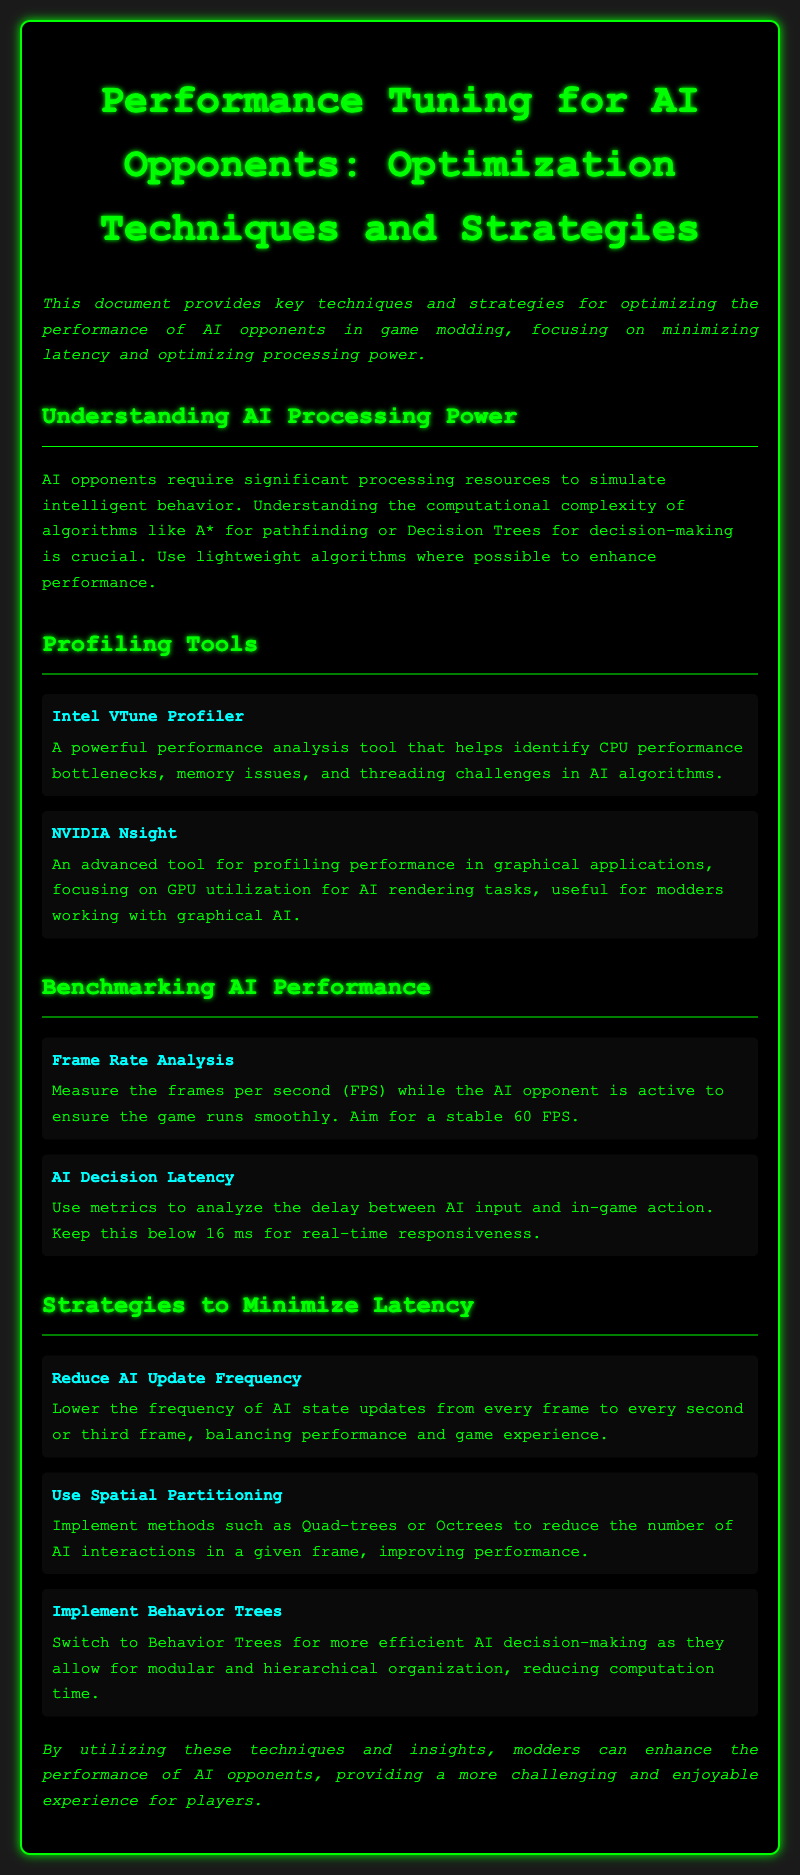What is the title of the document? The title of the document is provided at the top of the content, indicating the main subject covered.
Answer: Performance Tuning for AI Opponents: Optimization Techniques and Strategies What are the two profiling tools mentioned in the document? The document lists specific tools used for performance analysis which are detailed in the profiling tools section.
Answer: Intel VTune Profiler, NVIDIA Nsight What is the stable frame rate to aim for according to the benchmarks? The document specifies a target frame rate to ensure smooth gameplay as mentioned in the benchmarking section.
Answer: 60 FPS What is the maximum AI decision latency recommended for real-time responsiveness? The document outlines a threshold for AI decision latency to achieve a responsive gaming experience.
Answer: 16 ms Which strategy involves reducing AI state updates? This strategy is detailed in the strategies section where various methods to improve performance are discussed.
Answer: Reduce AI Update Frequency What organization method is suggested for efficient AI decision-making? The document provides specific methods for improving decision-making efficiency among AI opponents.
Answer: Behavior Trees What is one method mentioned for spatial partitioning? The document suggests techniques used to organize space and improve AI performance, specifying at least one method.
Answer: Quad-trees What is the primary focus of the introduction? The introduction outlines the objectives of the document regarding AI opponent performance optimization, which is clearly stated as the main aim.
Answer: Optimization of AI opponents 